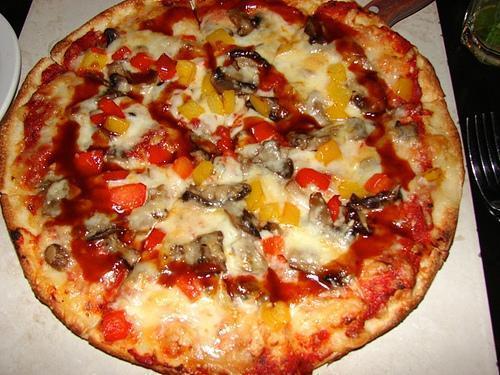How many pizzas are there?
Give a very brief answer. 3. 